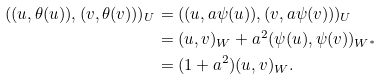Convert formula to latex. <formula><loc_0><loc_0><loc_500><loc_500>( ( u , \theta ( u ) ) , ( v , \theta ( v ) ) ) _ { U } & = ( ( u , a \psi ( u ) ) , ( v , a \psi ( v ) ) ) _ { U } \\ & = ( u , v ) _ { W } + a ^ { 2 } ( \psi ( u ) , \psi ( v ) ) _ { W ^ { * } } \\ & = ( 1 + a ^ { 2 } ) ( u , v ) _ { W } .</formula> 